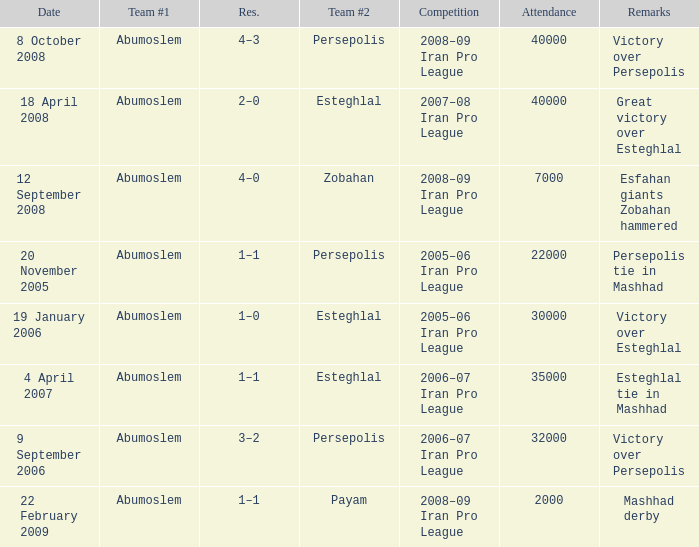Who was team #1 on 9 September 2006? Abumoslem. 